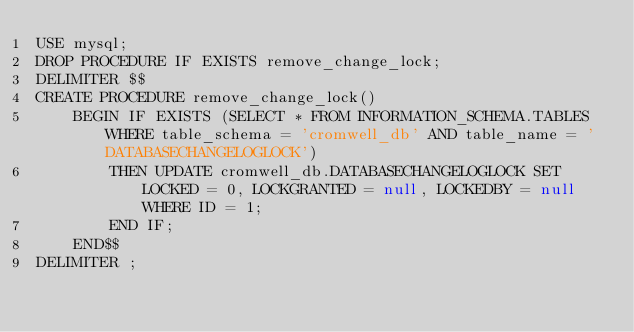<code> <loc_0><loc_0><loc_500><loc_500><_SQL_>USE mysql;
DROP PROCEDURE IF EXISTS remove_change_lock;
DELIMITER $$
CREATE PROCEDURE remove_change_lock()
    BEGIN IF EXISTS (SELECT * FROM INFORMATION_SCHEMA.TABLES WHERE table_schema = 'cromwell_db' AND table_name = 'DATABASECHANGELOGLOCK')
        THEN UPDATE cromwell_db.DATABASECHANGELOGLOCK SET LOCKED = 0, LOCKGRANTED = null, LOCKEDBY = null WHERE ID = 1;
        END IF;
    END$$
DELIMITER ;</code> 